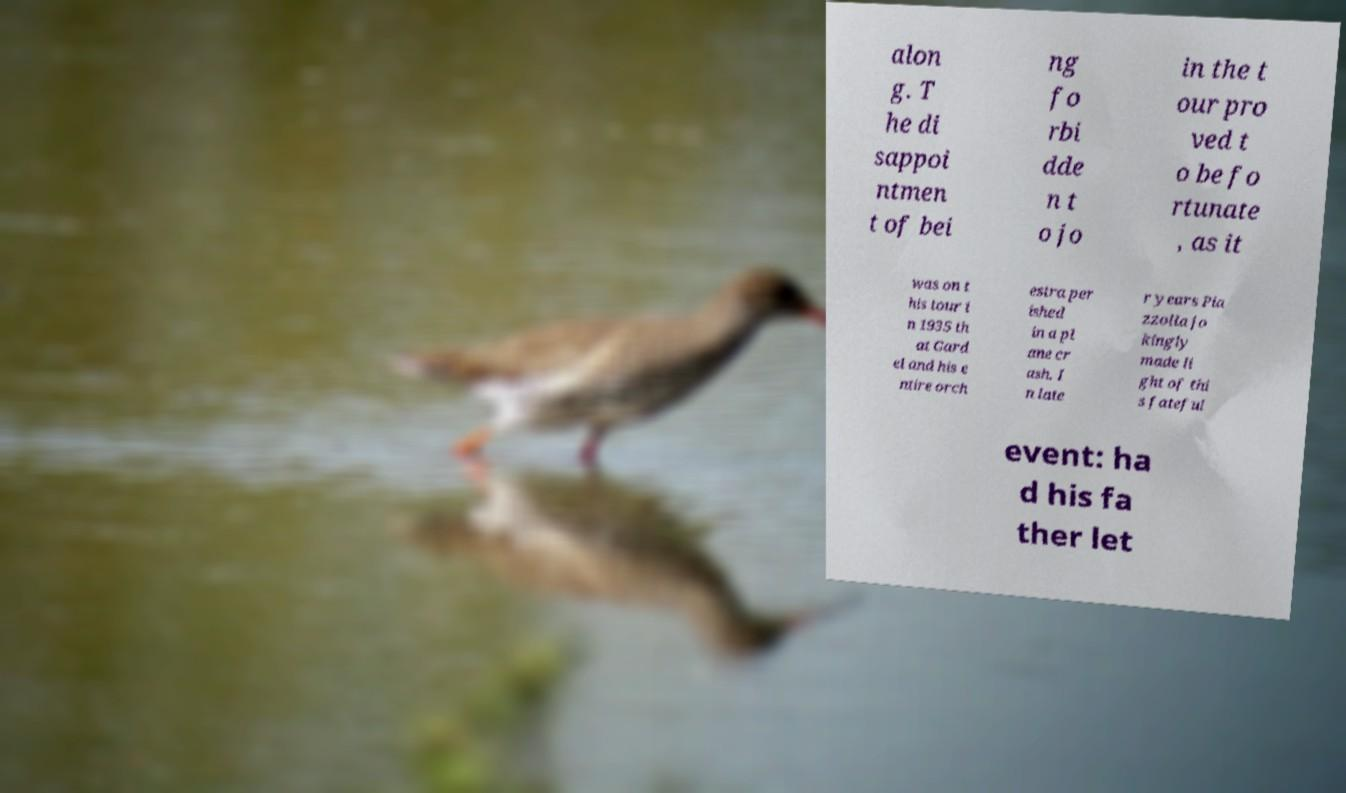What messages or text are displayed in this image? I need them in a readable, typed format. alon g. T he di sappoi ntmen t of bei ng fo rbi dde n t o jo in the t our pro ved t o be fo rtunate , as it was on t his tour i n 1935 th at Gard el and his e ntire orch estra per ished in a pl ane cr ash. I n late r years Pia zzolla jo kingly made li ght of thi s fateful event: ha d his fa ther let 